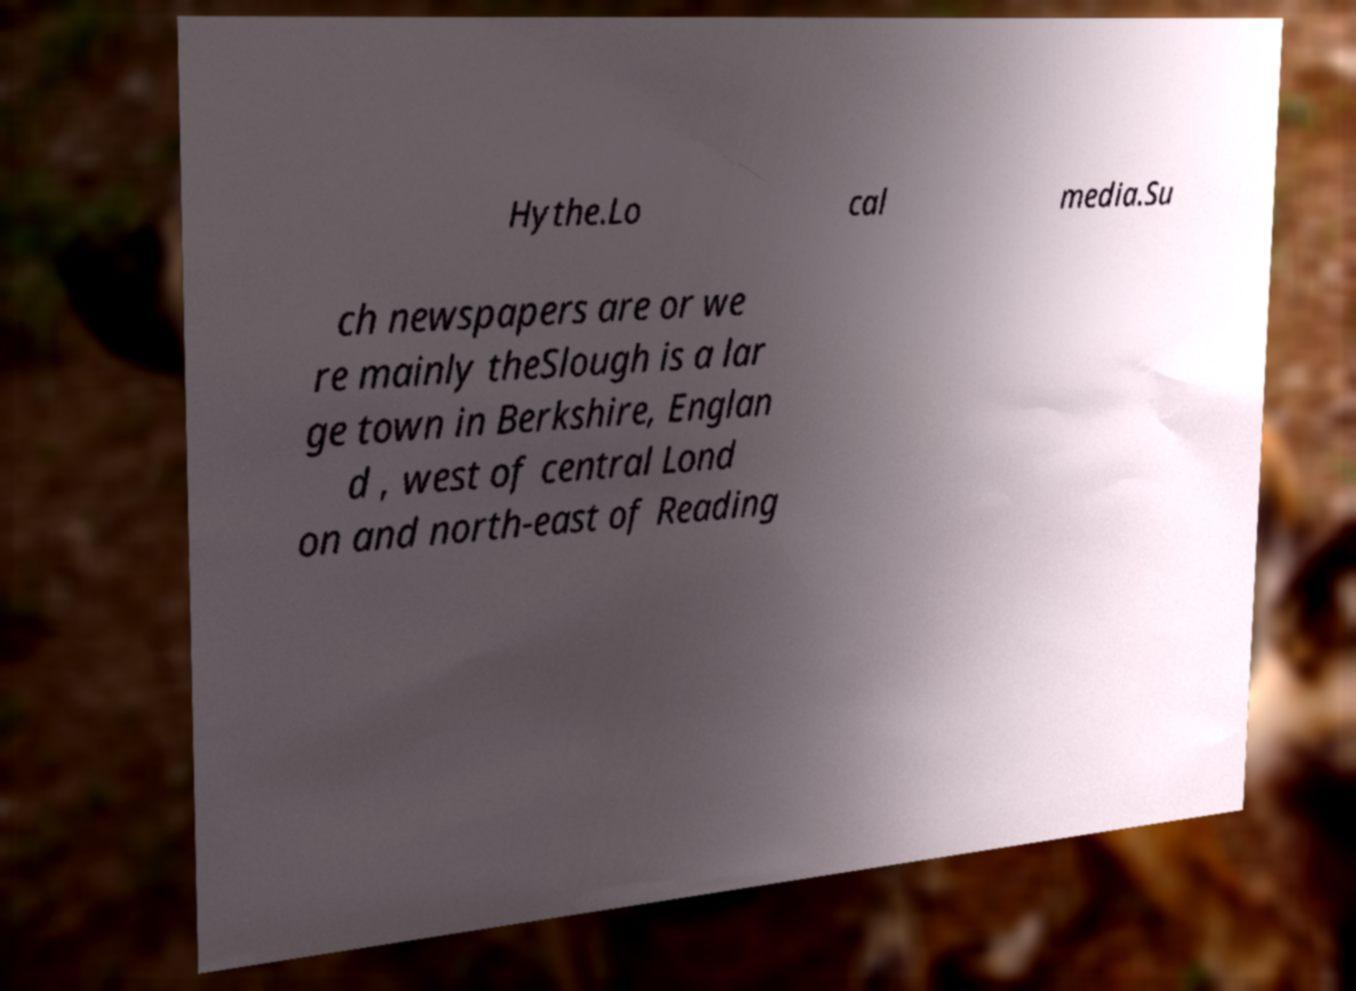I need the written content from this picture converted into text. Can you do that? Hythe.Lo cal media.Su ch newspapers are or we re mainly theSlough is a lar ge town in Berkshire, Englan d , west of central Lond on and north-east of Reading 